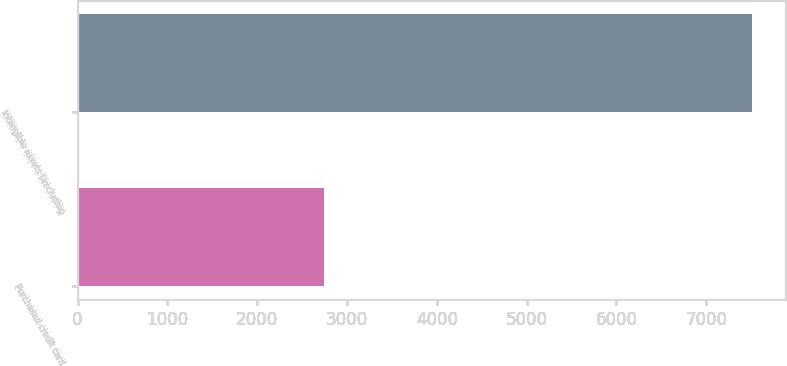Convert chart. <chart><loc_0><loc_0><loc_500><loc_500><bar_chart><fcel>Purchased credit card<fcel>Intangible assets (excluding<nl><fcel>2748<fcel>7504<nl></chart> 